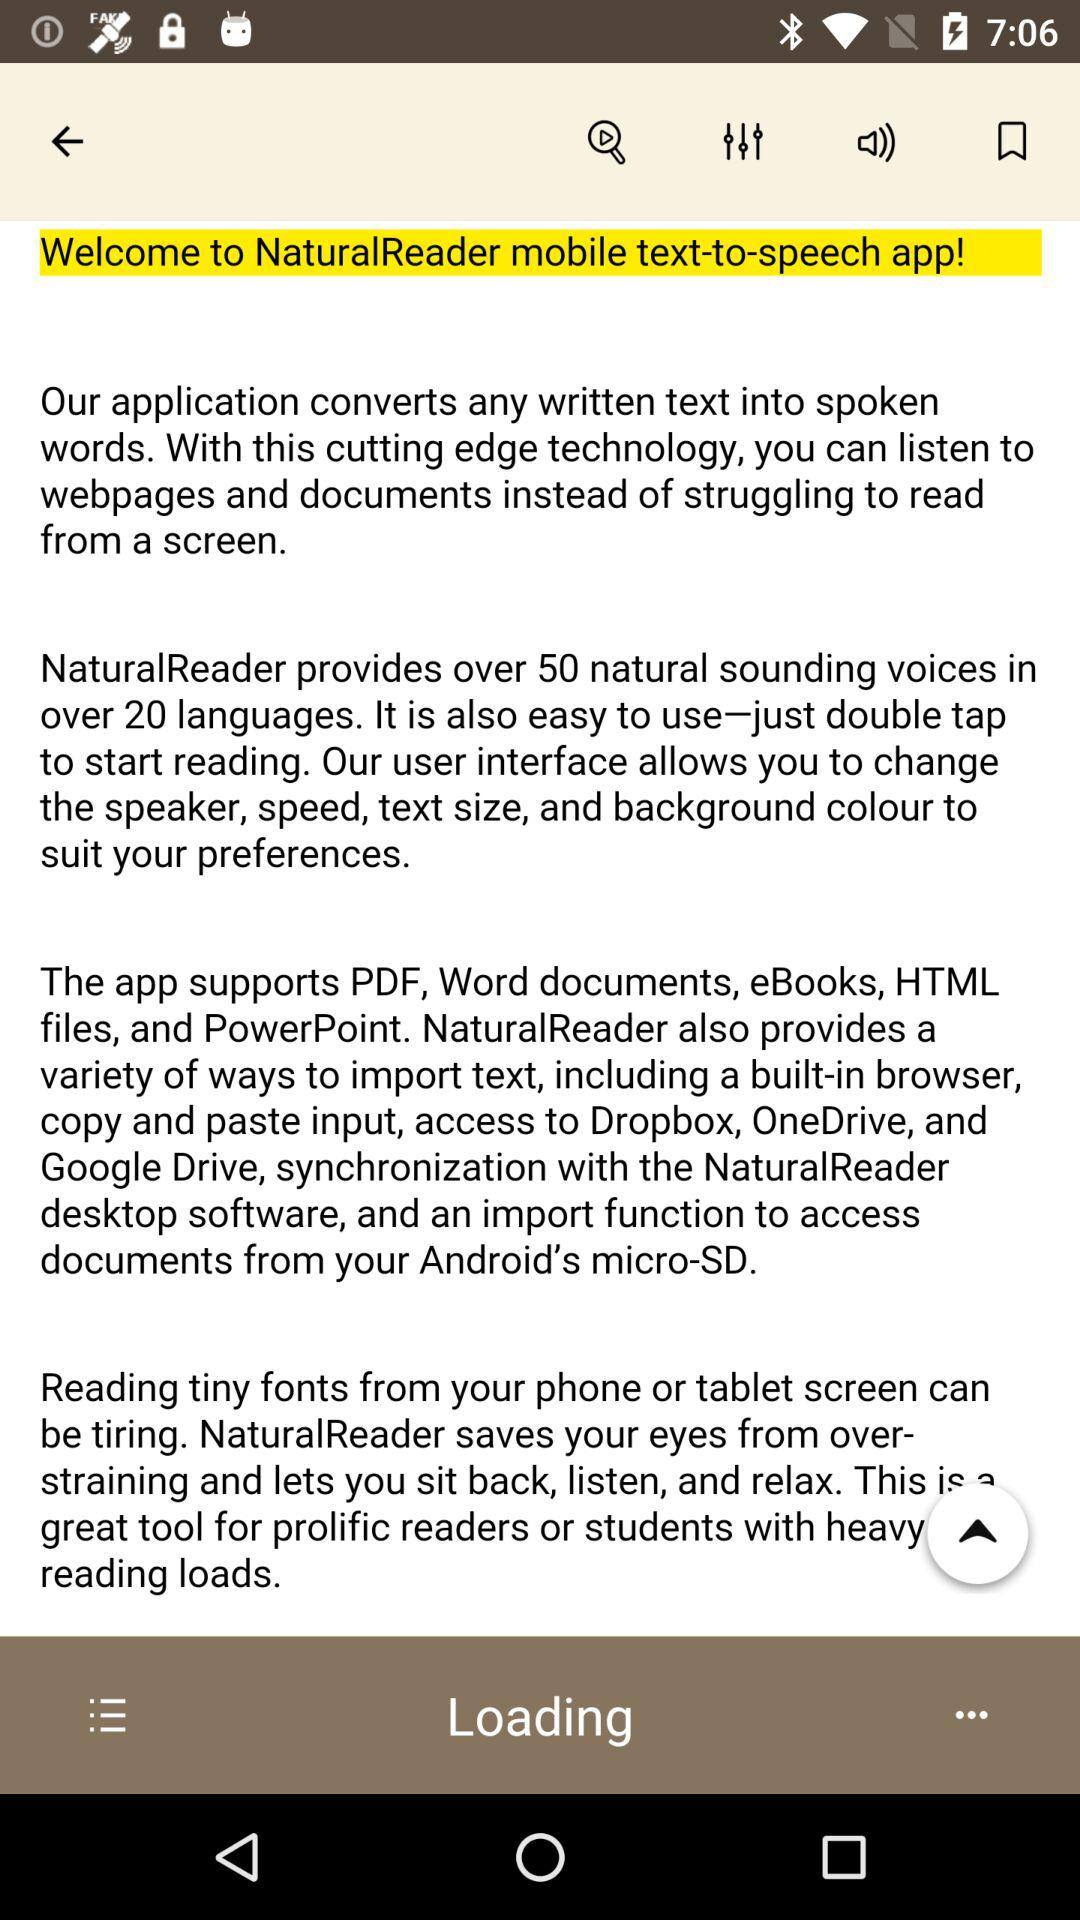How many ways does NaturalReader provide to import text?
Answer the question using a single word or phrase. 6 